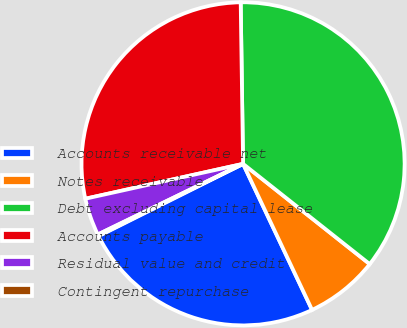Convert chart to OTSL. <chart><loc_0><loc_0><loc_500><loc_500><pie_chart><fcel>Accounts receivable net<fcel>Notes receivable<fcel>Debt excluding capital lease<fcel>Accounts payable<fcel>Residual value and credit<fcel>Contingent repurchase<nl><fcel>24.65%<fcel>7.32%<fcel>35.89%<fcel>28.23%<fcel>3.74%<fcel>0.17%<nl></chart> 